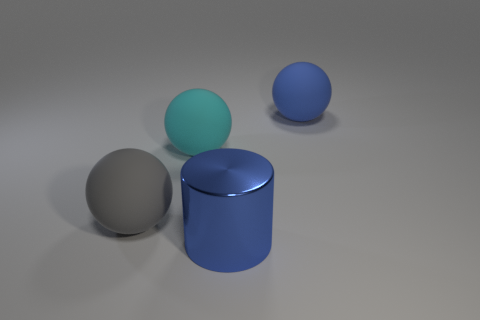What shapes are visible in the image, and do they have any distinctive features? The image exhibits a variety of geometric shapes. There is a sphere, which by definition is perfectly symmetrical. Another object is a cylinder that has two flat circular faces and one curved lateral surface. Lastly, there's another sphere that seems to be slightly smaller than the first. The distinctive features of these shapes include their polished surfaces and the varying shades of blue on the two larger objects, as well as the light they reflect, providing clues about their material and texture. 